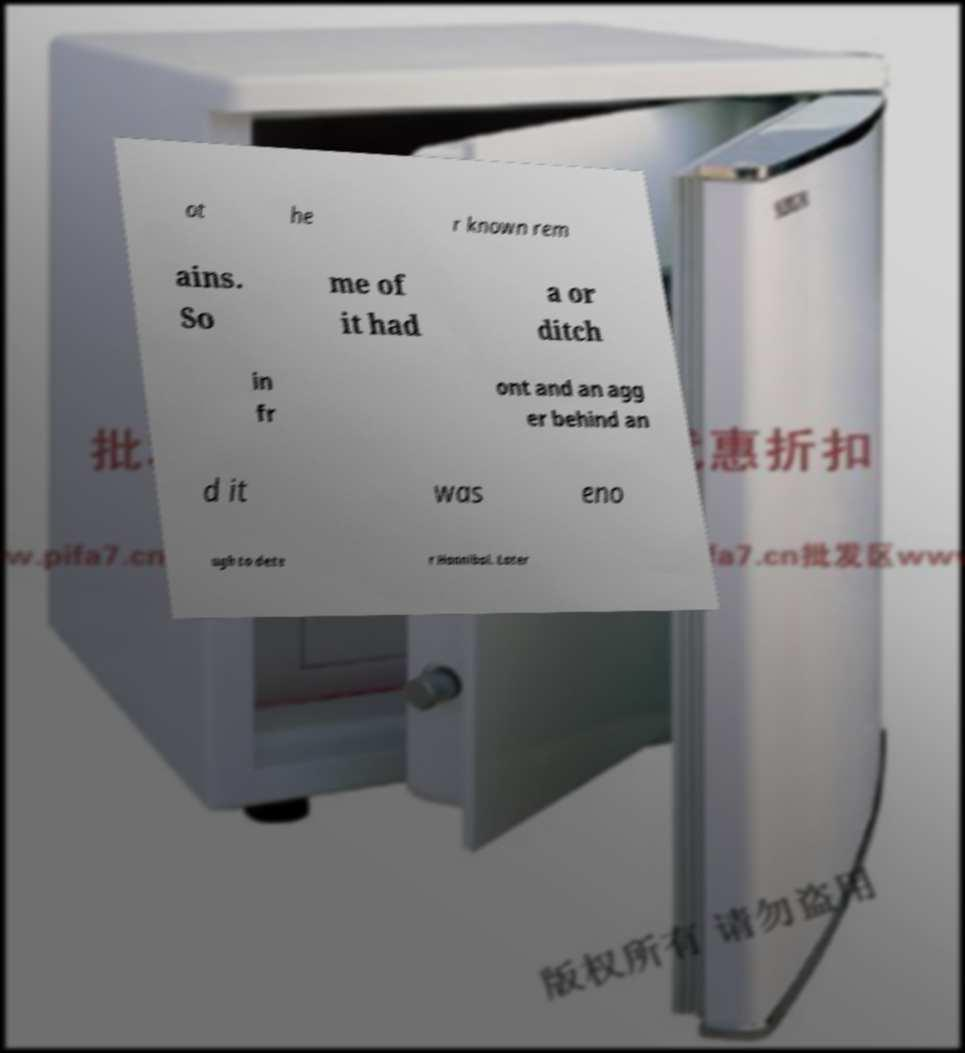Could you assist in decoding the text presented in this image and type it out clearly? ot he r known rem ains. So me of it had a or ditch in fr ont and an agg er behind an d it was eno ugh to dete r Hannibal. Later 